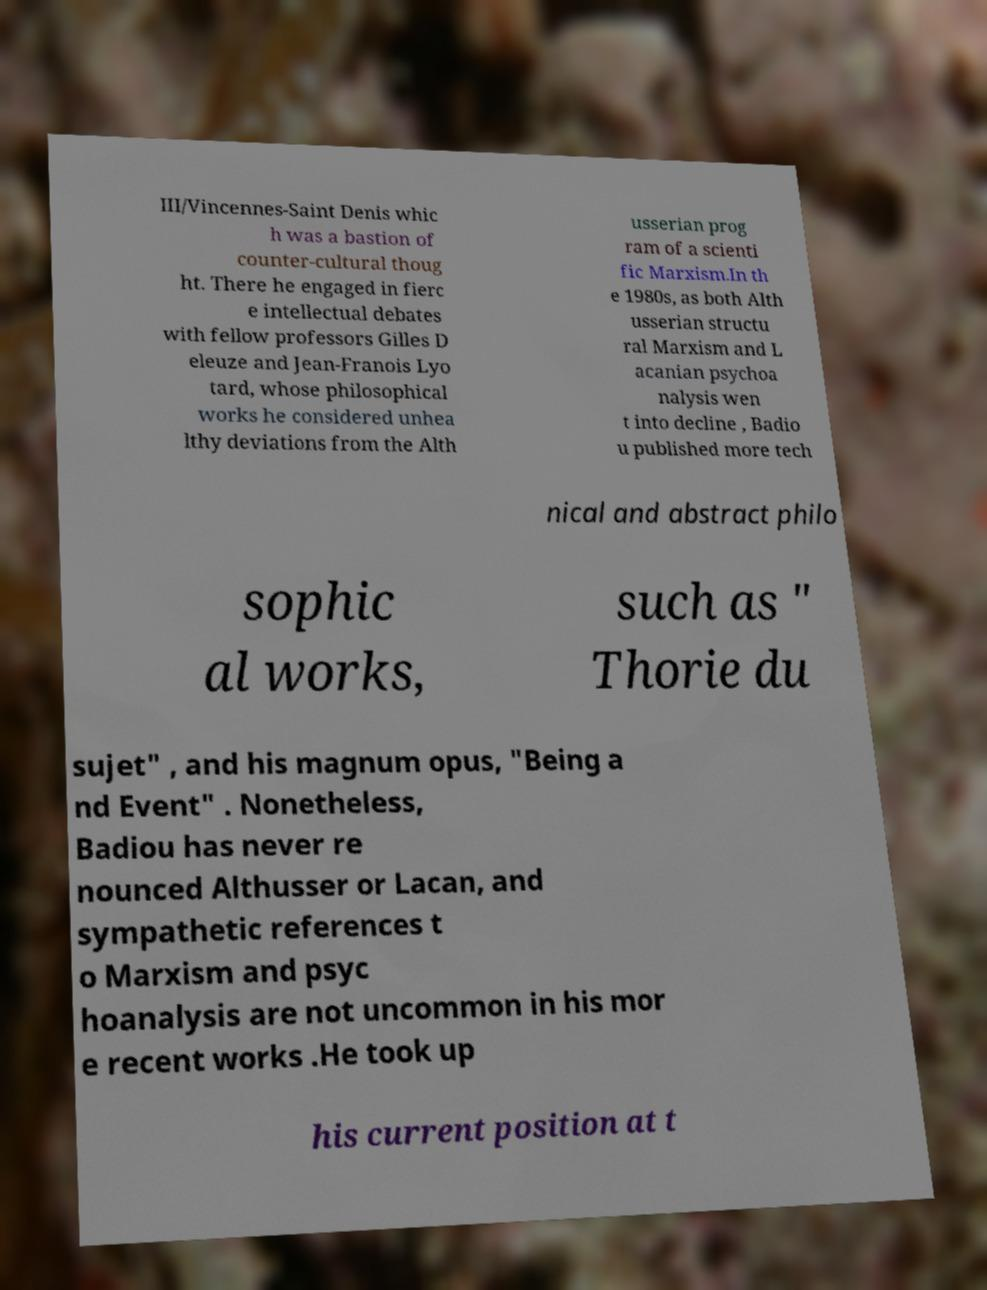What messages or text are displayed in this image? I need them in a readable, typed format. III/Vincennes-Saint Denis whic h was a bastion of counter-cultural thoug ht. There he engaged in fierc e intellectual debates with fellow professors Gilles D eleuze and Jean-Franois Lyo tard, whose philosophical works he considered unhea lthy deviations from the Alth usserian prog ram of a scienti fic Marxism.In th e 1980s, as both Alth usserian structu ral Marxism and L acanian psychoa nalysis wen t into decline , Badio u published more tech nical and abstract philo sophic al works, such as " Thorie du sujet" , and his magnum opus, "Being a nd Event" . Nonetheless, Badiou has never re nounced Althusser or Lacan, and sympathetic references t o Marxism and psyc hoanalysis are not uncommon in his mor e recent works .He took up his current position at t 